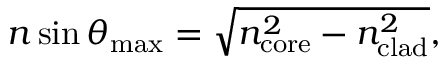Convert formula to latex. <formula><loc_0><loc_0><loc_500><loc_500>n \sin \theta _ { \max } = { \sqrt { n _ { c o r e } ^ { 2 } - n _ { c l a d } ^ { 2 } } } ,</formula> 